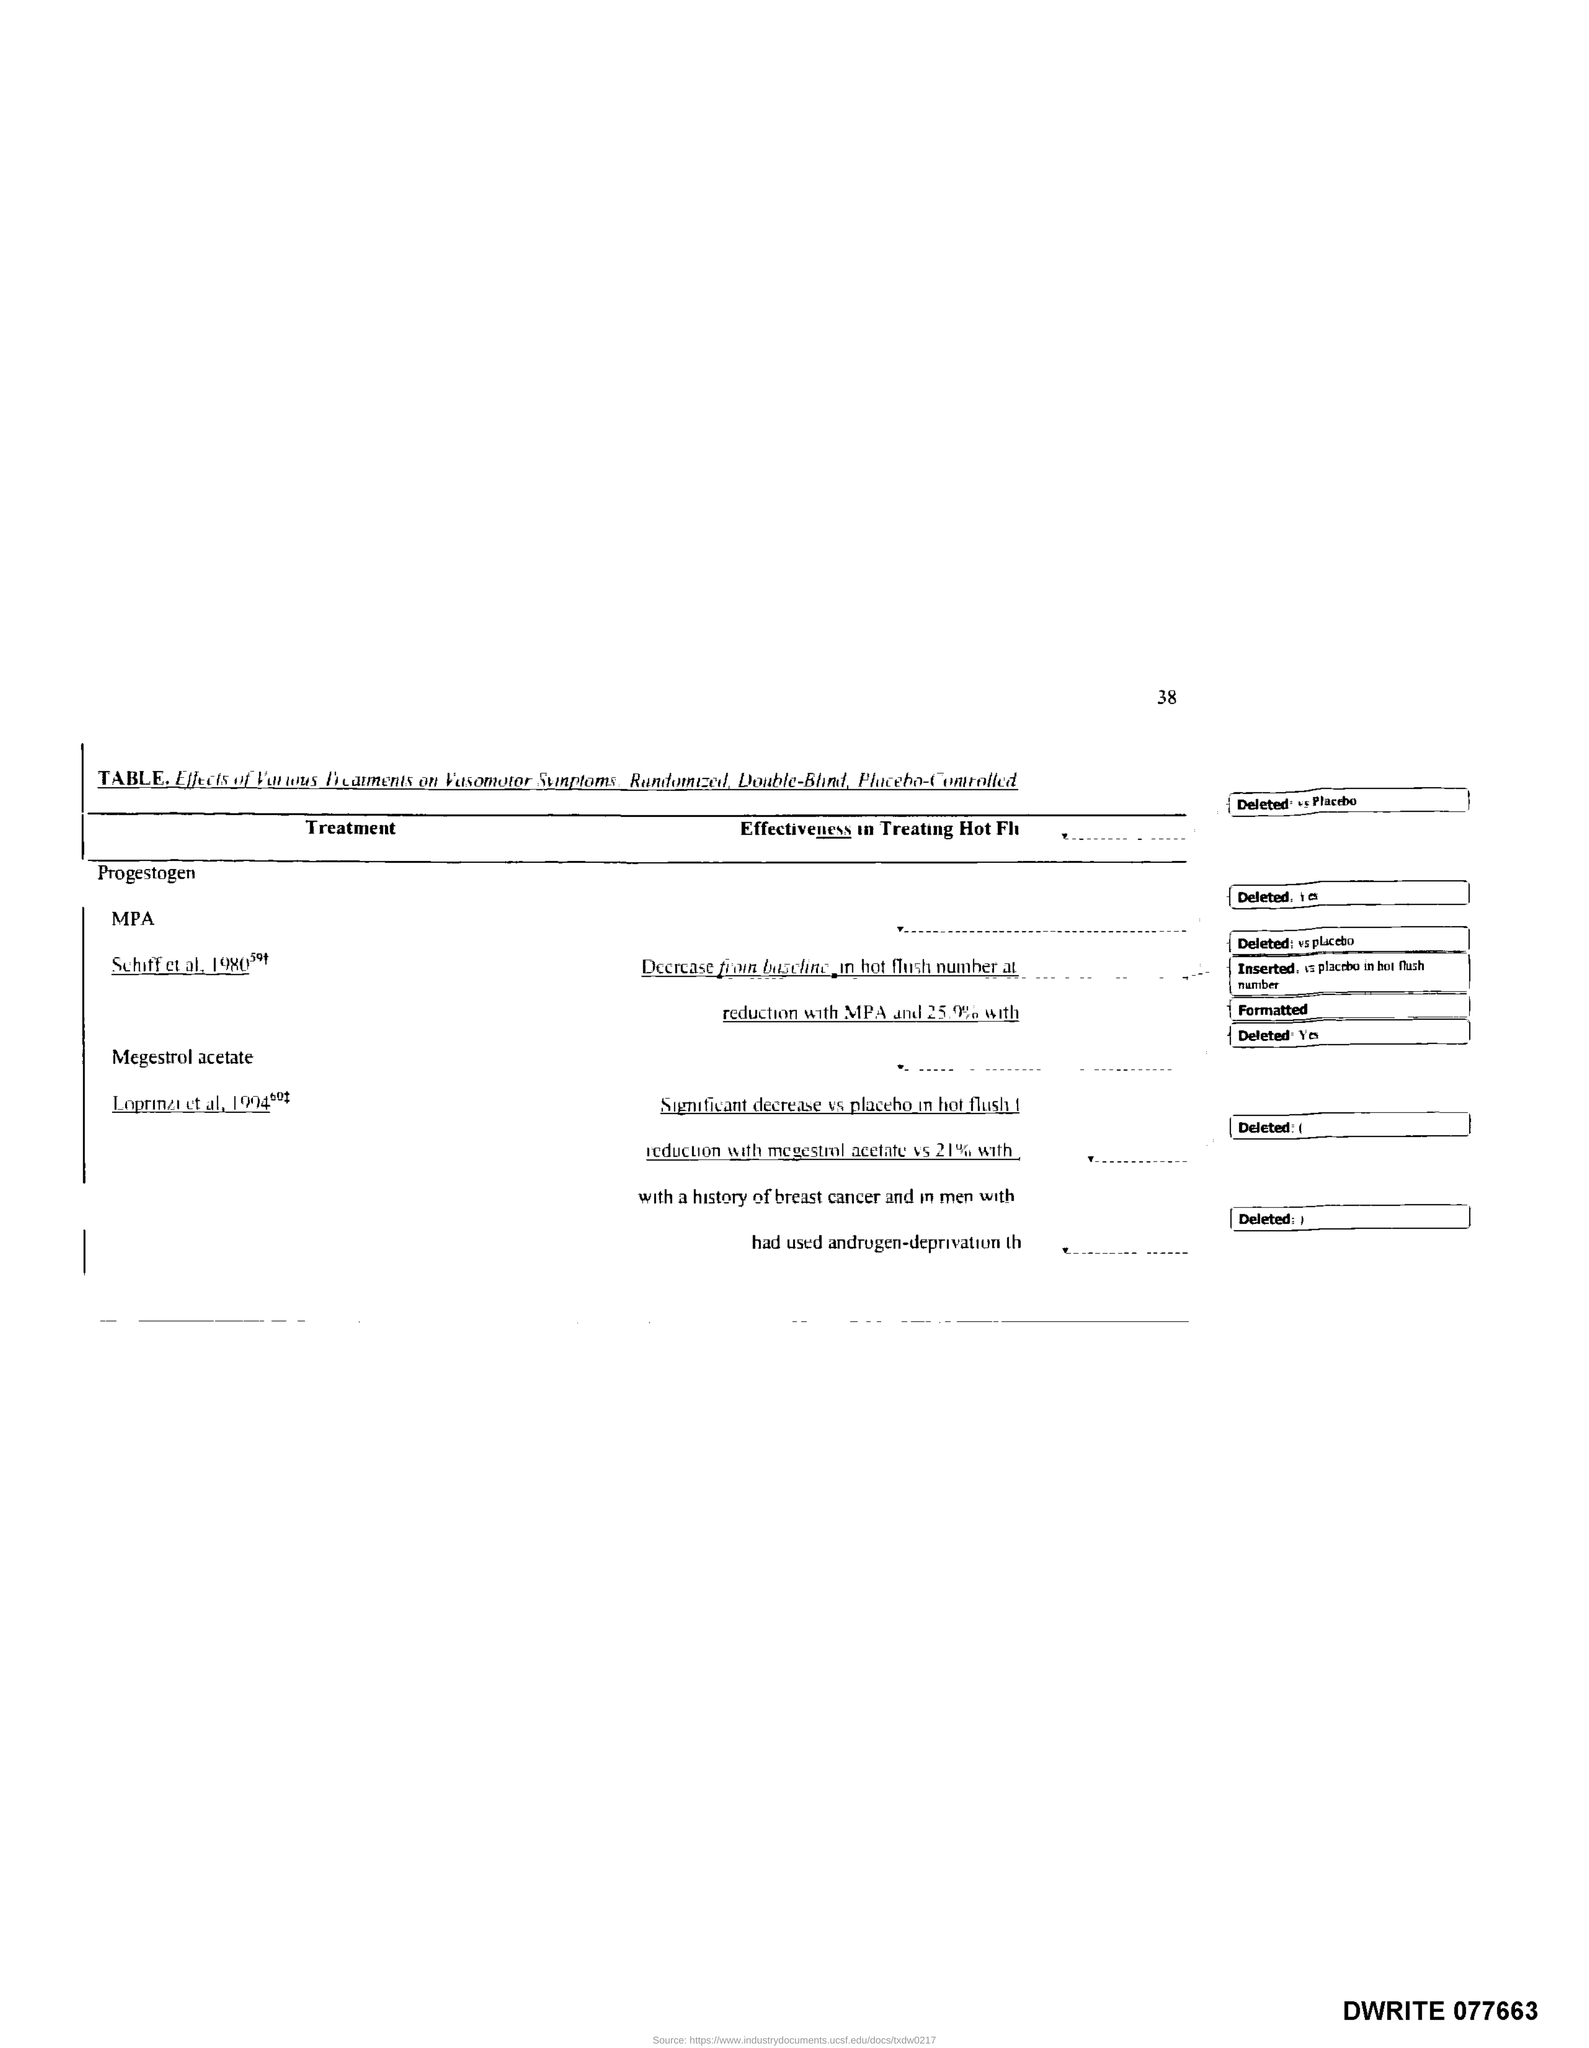What is the Page Number?
Make the answer very short. 38. 